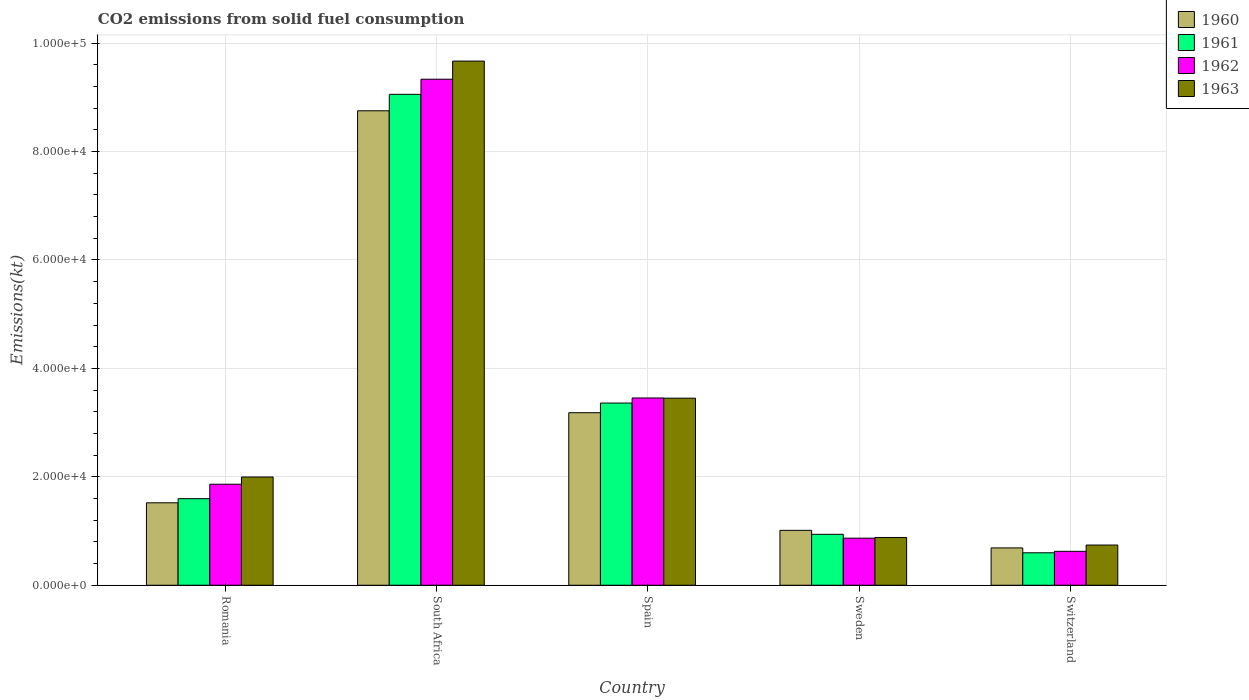How many different coloured bars are there?
Give a very brief answer. 4. How many groups of bars are there?
Provide a succinct answer. 5. Are the number of bars per tick equal to the number of legend labels?
Ensure brevity in your answer.  Yes. What is the label of the 5th group of bars from the left?
Keep it short and to the point. Switzerland. In how many cases, is the number of bars for a given country not equal to the number of legend labels?
Your answer should be compact. 0. What is the amount of CO2 emitted in 1962 in Spain?
Offer a terse response. 3.45e+04. Across all countries, what is the maximum amount of CO2 emitted in 1960?
Provide a short and direct response. 8.75e+04. Across all countries, what is the minimum amount of CO2 emitted in 1963?
Keep it short and to the point. 7414.67. In which country was the amount of CO2 emitted in 1960 maximum?
Keep it short and to the point. South Africa. In which country was the amount of CO2 emitted in 1960 minimum?
Offer a very short reply. Switzerland. What is the total amount of CO2 emitted in 1962 in the graph?
Provide a short and direct response. 1.61e+05. What is the difference between the amount of CO2 emitted in 1963 in Spain and that in Switzerland?
Your answer should be compact. 2.71e+04. What is the difference between the amount of CO2 emitted in 1962 in Spain and the amount of CO2 emitted in 1961 in Romania?
Ensure brevity in your answer.  1.86e+04. What is the average amount of CO2 emitted in 1961 per country?
Your response must be concise. 3.11e+04. What is the difference between the amount of CO2 emitted of/in 1960 and amount of CO2 emitted of/in 1963 in South Africa?
Give a very brief answer. -9167.5. In how many countries, is the amount of CO2 emitted in 1960 greater than 56000 kt?
Offer a very short reply. 1. What is the ratio of the amount of CO2 emitted in 1962 in Romania to that in Switzerland?
Provide a succinct answer. 2.98. What is the difference between the highest and the second highest amount of CO2 emitted in 1963?
Your answer should be very brief. 6.22e+04. What is the difference between the highest and the lowest amount of CO2 emitted in 1963?
Offer a very short reply. 8.93e+04. What does the 2nd bar from the left in Spain represents?
Make the answer very short. 1961. Are the values on the major ticks of Y-axis written in scientific E-notation?
Make the answer very short. Yes. Does the graph contain any zero values?
Offer a very short reply. No. Does the graph contain grids?
Your response must be concise. Yes. How many legend labels are there?
Offer a very short reply. 4. How are the legend labels stacked?
Offer a very short reply. Vertical. What is the title of the graph?
Ensure brevity in your answer.  CO2 emissions from solid fuel consumption. What is the label or title of the X-axis?
Your response must be concise. Country. What is the label or title of the Y-axis?
Give a very brief answer. Emissions(kt). What is the Emissions(kt) of 1960 in Romania?
Make the answer very short. 1.52e+04. What is the Emissions(kt) of 1961 in Romania?
Provide a short and direct response. 1.60e+04. What is the Emissions(kt) of 1962 in Romania?
Give a very brief answer. 1.86e+04. What is the Emissions(kt) in 1963 in Romania?
Provide a succinct answer. 2.00e+04. What is the Emissions(kt) of 1960 in South Africa?
Your response must be concise. 8.75e+04. What is the Emissions(kt) in 1961 in South Africa?
Your answer should be compact. 9.05e+04. What is the Emissions(kt) in 1962 in South Africa?
Provide a succinct answer. 9.33e+04. What is the Emissions(kt) of 1963 in South Africa?
Ensure brevity in your answer.  9.67e+04. What is the Emissions(kt) of 1960 in Spain?
Provide a short and direct response. 3.18e+04. What is the Emissions(kt) in 1961 in Spain?
Keep it short and to the point. 3.36e+04. What is the Emissions(kt) in 1962 in Spain?
Your answer should be very brief. 3.45e+04. What is the Emissions(kt) in 1963 in Spain?
Give a very brief answer. 3.45e+04. What is the Emissions(kt) of 1960 in Sweden?
Your answer should be compact. 1.01e+04. What is the Emissions(kt) in 1961 in Sweden?
Make the answer very short. 9394.85. What is the Emissions(kt) in 1962 in Sweden?
Your answer should be compact. 8683.46. What is the Emissions(kt) of 1963 in Sweden?
Ensure brevity in your answer.  8808.13. What is the Emissions(kt) of 1960 in Switzerland?
Provide a succinct answer. 6882.96. What is the Emissions(kt) of 1961 in Switzerland?
Offer a very short reply. 5984.54. What is the Emissions(kt) of 1962 in Switzerland?
Provide a succinct answer. 6255.9. What is the Emissions(kt) of 1963 in Switzerland?
Keep it short and to the point. 7414.67. Across all countries, what is the maximum Emissions(kt) in 1960?
Offer a terse response. 8.75e+04. Across all countries, what is the maximum Emissions(kt) in 1961?
Provide a short and direct response. 9.05e+04. Across all countries, what is the maximum Emissions(kt) in 1962?
Keep it short and to the point. 9.33e+04. Across all countries, what is the maximum Emissions(kt) of 1963?
Your response must be concise. 9.67e+04. Across all countries, what is the minimum Emissions(kt) in 1960?
Give a very brief answer. 6882.96. Across all countries, what is the minimum Emissions(kt) in 1961?
Provide a short and direct response. 5984.54. Across all countries, what is the minimum Emissions(kt) of 1962?
Your answer should be compact. 6255.9. Across all countries, what is the minimum Emissions(kt) of 1963?
Provide a short and direct response. 7414.67. What is the total Emissions(kt) in 1960 in the graph?
Your answer should be very brief. 1.52e+05. What is the total Emissions(kt) of 1961 in the graph?
Ensure brevity in your answer.  1.55e+05. What is the total Emissions(kt) of 1962 in the graph?
Your response must be concise. 1.61e+05. What is the total Emissions(kt) of 1963 in the graph?
Make the answer very short. 1.67e+05. What is the difference between the Emissions(kt) of 1960 in Romania and that in South Africa?
Provide a succinct answer. -7.23e+04. What is the difference between the Emissions(kt) in 1961 in Romania and that in South Africa?
Provide a succinct answer. -7.46e+04. What is the difference between the Emissions(kt) in 1962 in Romania and that in South Africa?
Ensure brevity in your answer.  -7.47e+04. What is the difference between the Emissions(kt) in 1963 in Romania and that in South Africa?
Your response must be concise. -7.67e+04. What is the difference between the Emissions(kt) of 1960 in Romania and that in Spain?
Ensure brevity in your answer.  -1.66e+04. What is the difference between the Emissions(kt) in 1961 in Romania and that in Spain?
Ensure brevity in your answer.  -1.76e+04. What is the difference between the Emissions(kt) in 1962 in Romania and that in Spain?
Offer a very short reply. -1.59e+04. What is the difference between the Emissions(kt) in 1963 in Romania and that in Spain?
Offer a terse response. -1.45e+04. What is the difference between the Emissions(kt) of 1960 in Romania and that in Sweden?
Your answer should be very brief. 5078.8. What is the difference between the Emissions(kt) of 1961 in Romania and that in Sweden?
Give a very brief answer. 6574.93. What is the difference between the Emissions(kt) in 1962 in Romania and that in Sweden?
Your answer should be compact. 9948.57. What is the difference between the Emissions(kt) of 1963 in Romania and that in Sweden?
Offer a terse response. 1.12e+04. What is the difference between the Emissions(kt) in 1960 in Romania and that in Switzerland?
Provide a succinct answer. 8320.42. What is the difference between the Emissions(kt) in 1961 in Romania and that in Switzerland?
Provide a short and direct response. 9985.24. What is the difference between the Emissions(kt) in 1962 in Romania and that in Switzerland?
Your answer should be compact. 1.24e+04. What is the difference between the Emissions(kt) of 1963 in Romania and that in Switzerland?
Your answer should be very brief. 1.26e+04. What is the difference between the Emissions(kt) of 1960 in South Africa and that in Spain?
Provide a succinct answer. 5.57e+04. What is the difference between the Emissions(kt) of 1961 in South Africa and that in Spain?
Your answer should be very brief. 5.69e+04. What is the difference between the Emissions(kt) of 1962 in South Africa and that in Spain?
Offer a very short reply. 5.88e+04. What is the difference between the Emissions(kt) of 1963 in South Africa and that in Spain?
Offer a terse response. 6.22e+04. What is the difference between the Emissions(kt) of 1960 in South Africa and that in Sweden?
Give a very brief answer. 7.74e+04. What is the difference between the Emissions(kt) of 1961 in South Africa and that in Sweden?
Give a very brief answer. 8.12e+04. What is the difference between the Emissions(kt) in 1962 in South Africa and that in Sweden?
Keep it short and to the point. 8.47e+04. What is the difference between the Emissions(kt) of 1963 in South Africa and that in Sweden?
Ensure brevity in your answer.  8.79e+04. What is the difference between the Emissions(kt) in 1960 in South Africa and that in Switzerland?
Provide a short and direct response. 8.06e+04. What is the difference between the Emissions(kt) of 1961 in South Africa and that in Switzerland?
Offer a very short reply. 8.46e+04. What is the difference between the Emissions(kt) of 1962 in South Africa and that in Switzerland?
Keep it short and to the point. 8.71e+04. What is the difference between the Emissions(kt) in 1963 in South Africa and that in Switzerland?
Provide a succinct answer. 8.93e+04. What is the difference between the Emissions(kt) in 1960 in Spain and that in Sweden?
Keep it short and to the point. 2.17e+04. What is the difference between the Emissions(kt) in 1961 in Spain and that in Sweden?
Offer a very short reply. 2.42e+04. What is the difference between the Emissions(kt) of 1962 in Spain and that in Sweden?
Offer a very short reply. 2.59e+04. What is the difference between the Emissions(kt) in 1963 in Spain and that in Sweden?
Give a very brief answer. 2.57e+04. What is the difference between the Emissions(kt) in 1960 in Spain and that in Switzerland?
Ensure brevity in your answer.  2.49e+04. What is the difference between the Emissions(kt) in 1961 in Spain and that in Switzerland?
Make the answer very short. 2.76e+04. What is the difference between the Emissions(kt) in 1962 in Spain and that in Switzerland?
Offer a very short reply. 2.83e+04. What is the difference between the Emissions(kt) in 1963 in Spain and that in Switzerland?
Your response must be concise. 2.71e+04. What is the difference between the Emissions(kt) of 1960 in Sweden and that in Switzerland?
Your response must be concise. 3241.63. What is the difference between the Emissions(kt) in 1961 in Sweden and that in Switzerland?
Your answer should be very brief. 3410.31. What is the difference between the Emissions(kt) in 1962 in Sweden and that in Switzerland?
Provide a short and direct response. 2427.55. What is the difference between the Emissions(kt) of 1963 in Sweden and that in Switzerland?
Provide a short and direct response. 1393.46. What is the difference between the Emissions(kt) in 1960 in Romania and the Emissions(kt) in 1961 in South Africa?
Keep it short and to the point. -7.53e+04. What is the difference between the Emissions(kt) in 1960 in Romania and the Emissions(kt) in 1962 in South Africa?
Keep it short and to the point. -7.81e+04. What is the difference between the Emissions(kt) in 1960 in Romania and the Emissions(kt) in 1963 in South Africa?
Offer a very short reply. -8.15e+04. What is the difference between the Emissions(kt) in 1961 in Romania and the Emissions(kt) in 1962 in South Africa?
Offer a terse response. -7.74e+04. What is the difference between the Emissions(kt) of 1961 in Romania and the Emissions(kt) of 1963 in South Africa?
Provide a succinct answer. -8.07e+04. What is the difference between the Emissions(kt) in 1962 in Romania and the Emissions(kt) in 1963 in South Africa?
Ensure brevity in your answer.  -7.80e+04. What is the difference between the Emissions(kt) in 1960 in Romania and the Emissions(kt) in 1961 in Spain?
Offer a very short reply. -1.84e+04. What is the difference between the Emissions(kt) in 1960 in Romania and the Emissions(kt) in 1962 in Spain?
Your response must be concise. -1.93e+04. What is the difference between the Emissions(kt) of 1960 in Romania and the Emissions(kt) of 1963 in Spain?
Provide a short and direct response. -1.93e+04. What is the difference between the Emissions(kt) in 1961 in Romania and the Emissions(kt) in 1962 in Spain?
Ensure brevity in your answer.  -1.86e+04. What is the difference between the Emissions(kt) in 1961 in Romania and the Emissions(kt) in 1963 in Spain?
Your answer should be compact. -1.85e+04. What is the difference between the Emissions(kt) in 1962 in Romania and the Emissions(kt) in 1963 in Spain?
Make the answer very short. -1.59e+04. What is the difference between the Emissions(kt) of 1960 in Romania and the Emissions(kt) of 1961 in Sweden?
Offer a terse response. 5808.53. What is the difference between the Emissions(kt) of 1960 in Romania and the Emissions(kt) of 1962 in Sweden?
Your answer should be very brief. 6519.93. What is the difference between the Emissions(kt) of 1960 in Romania and the Emissions(kt) of 1963 in Sweden?
Provide a short and direct response. 6395.25. What is the difference between the Emissions(kt) in 1961 in Romania and the Emissions(kt) in 1962 in Sweden?
Provide a succinct answer. 7286.33. What is the difference between the Emissions(kt) in 1961 in Romania and the Emissions(kt) in 1963 in Sweden?
Ensure brevity in your answer.  7161.65. What is the difference between the Emissions(kt) of 1962 in Romania and the Emissions(kt) of 1963 in Sweden?
Offer a terse response. 9823.89. What is the difference between the Emissions(kt) in 1960 in Romania and the Emissions(kt) in 1961 in Switzerland?
Your response must be concise. 9218.84. What is the difference between the Emissions(kt) of 1960 in Romania and the Emissions(kt) of 1962 in Switzerland?
Ensure brevity in your answer.  8947.48. What is the difference between the Emissions(kt) in 1960 in Romania and the Emissions(kt) in 1963 in Switzerland?
Offer a terse response. 7788.71. What is the difference between the Emissions(kt) in 1961 in Romania and the Emissions(kt) in 1962 in Switzerland?
Offer a terse response. 9713.88. What is the difference between the Emissions(kt) of 1961 in Romania and the Emissions(kt) of 1963 in Switzerland?
Ensure brevity in your answer.  8555.11. What is the difference between the Emissions(kt) of 1962 in Romania and the Emissions(kt) of 1963 in Switzerland?
Your response must be concise. 1.12e+04. What is the difference between the Emissions(kt) of 1960 in South Africa and the Emissions(kt) of 1961 in Spain?
Your response must be concise. 5.39e+04. What is the difference between the Emissions(kt) in 1960 in South Africa and the Emissions(kt) in 1962 in Spain?
Your answer should be very brief. 5.30e+04. What is the difference between the Emissions(kt) in 1960 in South Africa and the Emissions(kt) in 1963 in Spain?
Make the answer very short. 5.30e+04. What is the difference between the Emissions(kt) of 1961 in South Africa and the Emissions(kt) of 1962 in Spain?
Your answer should be very brief. 5.60e+04. What is the difference between the Emissions(kt) of 1961 in South Africa and the Emissions(kt) of 1963 in Spain?
Make the answer very short. 5.60e+04. What is the difference between the Emissions(kt) of 1962 in South Africa and the Emissions(kt) of 1963 in Spain?
Keep it short and to the point. 5.88e+04. What is the difference between the Emissions(kt) of 1960 in South Africa and the Emissions(kt) of 1961 in Sweden?
Give a very brief answer. 7.81e+04. What is the difference between the Emissions(kt) of 1960 in South Africa and the Emissions(kt) of 1962 in Sweden?
Offer a very short reply. 7.88e+04. What is the difference between the Emissions(kt) of 1960 in South Africa and the Emissions(kt) of 1963 in Sweden?
Offer a very short reply. 7.87e+04. What is the difference between the Emissions(kt) of 1961 in South Africa and the Emissions(kt) of 1962 in Sweden?
Keep it short and to the point. 8.19e+04. What is the difference between the Emissions(kt) in 1961 in South Africa and the Emissions(kt) in 1963 in Sweden?
Ensure brevity in your answer.  8.17e+04. What is the difference between the Emissions(kt) in 1962 in South Africa and the Emissions(kt) in 1963 in Sweden?
Ensure brevity in your answer.  8.45e+04. What is the difference between the Emissions(kt) in 1960 in South Africa and the Emissions(kt) in 1961 in Switzerland?
Offer a terse response. 8.15e+04. What is the difference between the Emissions(kt) in 1960 in South Africa and the Emissions(kt) in 1962 in Switzerland?
Keep it short and to the point. 8.13e+04. What is the difference between the Emissions(kt) of 1960 in South Africa and the Emissions(kt) of 1963 in Switzerland?
Offer a very short reply. 8.01e+04. What is the difference between the Emissions(kt) in 1961 in South Africa and the Emissions(kt) in 1962 in Switzerland?
Offer a terse response. 8.43e+04. What is the difference between the Emissions(kt) in 1961 in South Africa and the Emissions(kt) in 1963 in Switzerland?
Make the answer very short. 8.31e+04. What is the difference between the Emissions(kt) of 1962 in South Africa and the Emissions(kt) of 1963 in Switzerland?
Provide a succinct answer. 8.59e+04. What is the difference between the Emissions(kt) in 1960 in Spain and the Emissions(kt) in 1961 in Sweden?
Ensure brevity in your answer.  2.24e+04. What is the difference between the Emissions(kt) in 1960 in Spain and the Emissions(kt) in 1962 in Sweden?
Provide a short and direct response. 2.31e+04. What is the difference between the Emissions(kt) of 1960 in Spain and the Emissions(kt) of 1963 in Sweden?
Offer a very short reply. 2.30e+04. What is the difference between the Emissions(kt) in 1961 in Spain and the Emissions(kt) in 1962 in Sweden?
Give a very brief answer. 2.49e+04. What is the difference between the Emissions(kt) of 1961 in Spain and the Emissions(kt) of 1963 in Sweden?
Your response must be concise. 2.48e+04. What is the difference between the Emissions(kt) in 1962 in Spain and the Emissions(kt) in 1963 in Sweden?
Ensure brevity in your answer.  2.57e+04. What is the difference between the Emissions(kt) in 1960 in Spain and the Emissions(kt) in 1961 in Switzerland?
Give a very brief answer. 2.58e+04. What is the difference between the Emissions(kt) of 1960 in Spain and the Emissions(kt) of 1962 in Switzerland?
Provide a succinct answer. 2.56e+04. What is the difference between the Emissions(kt) in 1960 in Spain and the Emissions(kt) in 1963 in Switzerland?
Offer a very short reply. 2.44e+04. What is the difference between the Emissions(kt) in 1961 in Spain and the Emissions(kt) in 1962 in Switzerland?
Offer a terse response. 2.73e+04. What is the difference between the Emissions(kt) in 1961 in Spain and the Emissions(kt) in 1963 in Switzerland?
Provide a short and direct response. 2.62e+04. What is the difference between the Emissions(kt) of 1962 in Spain and the Emissions(kt) of 1963 in Switzerland?
Offer a terse response. 2.71e+04. What is the difference between the Emissions(kt) in 1960 in Sweden and the Emissions(kt) in 1961 in Switzerland?
Give a very brief answer. 4140.04. What is the difference between the Emissions(kt) in 1960 in Sweden and the Emissions(kt) in 1962 in Switzerland?
Keep it short and to the point. 3868.68. What is the difference between the Emissions(kt) of 1960 in Sweden and the Emissions(kt) of 1963 in Switzerland?
Keep it short and to the point. 2709.91. What is the difference between the Emissions(kt) in 1961 in Sweden and the Emissions(kt) in 1962 in Switzerland?
Keep it short and to the point. 3138.95. What is the difference between the Emissions(kt) of 1961 in Sweden and the Emissions(kt) of 1963 in Switzerland?
Provide a succinct answer. 1980.18. What is the difference between the Emissions(kt) of 1962 in Sweden and the Emissions(kt) of 1963 in Switzerland?
Ensure brevity in your answer.  1268.78. What is the average Emissions(kt) in 1960 per country?
Ensure brevity in your answer.  3.03e+04. What is the average Emissions(kt) in 1961 per country?
Ensure brevity in your answer.  3.11e+04. What is the average Emissions(kt) of 1962 per country?
Your response must be concise. 3.23e+04. What is the average Emissions(kt) in 1963 per country?
Give a very brief answer. 3.35e+04. What is the difference between the Emissions(kt) in 1960 and Emissions(kt) in 1961 in Romania?
Your response must be concise. -766.4. What is the difference between the Emissions(kt) of 1960 and Emissions(kt) of 1962 in Romania?
Offer a terse response. -3428.64. What is the difference between the Emissions(kt) of 1960 and Emissions(kt) of 1963 in Romania?
Provide a short and direct response. -4763.43. What is the difference between the Emissions(kt) in 1961 and Emissions(kt) in 1962 in Romania?
Offer a terse response. -2662.24. What is the difference between the Emissions(kt) in 1961 and Emissions(kt) in 1963 in Romania?
Provide a short and direct response. -3997.03. What is the difference between the Emissions(kt) in 1962 and Emissions(kt) in 1963 in Romania?
Make the answer very short. -1334.79. What is the difference between the Emissions(kt) in 1960 and Emissions(kt) in 1961 in South Africa?
Your answer should be very brief. -3032.61. What is the difference between the Emissions(kt) in 1960 and Emissions(kt) in 1962 in South Africa?
Make the answer very short. -5823.2. What is the difference between the Emissions(kt) in 1960 and Emissions(kt) in 1963 in South Africa?
Provide a succinct answer. -9167.5. What is the difference between the Emissions(kt) of 1961 and Emissions(kt) of 1962 in South Africa?
Give a very brief answer. -2790.59. What is the difference between the Emissions(kt) in 1961 and Emissions(kt) in 1963 in South Africa?
Ensure brevity in your answer.  -6134.89. What is the difference between the Emissions(kt) of 1962 and Emissions(kt) of 1963 in South Africa?
Your answer should be compact. -3344.3. What is the difference between the Emissions(kt) in 1960 and Emissions(kt) in 1961 in Spain?
Provide a short and direct response. -1782.16. What is the difference between the Emissions(kt) of 1960 and Emissions(kt) of 1962 in Spain?
Make the answer very short. -2720.91. What is the difference between the Emissions(kt) in 1960 and Emissions(kt) in 1963 in Spain?
Your answer should be compact. -2684.24. What is the difference between the Emissions(kt) of 1961 and Emissions(kt) of 1962 in Spain?
Make the answer very short. -938.75. What is the difference between the Emissions(kt) in 1961 and Emissions(kt) in 1963 in Spain?
Make the answer very short. -902.08. What is the difference between the Emissions(kt) of 1962 and Emissions(kt) of 1963 in Spain?
Provide a short and direct response. 36.67. What is the difference between the Emissions(kt) in 1960 and Emissions(kt) in 1961 in Sweden?
Your answer should be very brief. 729.73. What is the difference between the Emissions(kt) in 1960 and Emissions(kt) in 1962 in Sweden?
Provide a short and direct response. 1441.13. What is the difference between the Emissions(kt) of 1960 and Emissions(kt) of 1963 in Sweden?
Make the answer very short. 1316.45. What is the difference between the Emissions(kt) of 1961 and Emissions(kt) of 1962 in Sweden?
Offer a very short reply. 711.4. What is the difference between the Emissions(kt) in 1961 and Emissions(kt) in 1963 in Sweden?
Your answer should be very brief. 586.72. What is the difference between the Emissions(kt) in 1962 and Emissions(kt) in 1963 in Sweden?
Offer a terse response. -124.68. What is the difference between the Emissions(kt) of 1960 and Emissions(kt) of 1961 in Switzerland?
Provide a short and direct response. 898.41. What is the difference between the Emissions(kt) in 1960 and Emissions(kt) in 1962 in Switzerland?
Offer a terse response. 627.06. What is the difference between the Emissions(kt) of 1960 and Emissions(kt) of 1963 in Switzerland?
Keep it short and to the point. -531.72. What is the difference between the Emissions(kt) in 1961 and Emissions(kt) in 1962 in Switzerland?
Make the answer very short. -271.36. What is the difference between the Emissions(kt) in 1961 and Emissions(kt) in 1963 in Switzerland?
Offer a terse response. -1430.13. What is the difference between the Emissions(kt) in 1962 and Emissions(kt) in 1963 in Switzerland?
Your response must be concise. -1158.77. What is the ratio of the Emissions(kt) of 1960 in Romania to that in South Africa?
Provide a short and direct response. 0.17. What is the ratio of the Emissions(kt) in 1961 in Romania to that in South Africa?
Offer a terse response. 0.18. What is the ratio of the Emissions(kt) in 1962 in Romania to that in South Africa?
Make the answer very short. 0.2. What is the ratio of the Emissions(kt) in 1963 in Romania to that in South Africa?
Give a very brief answer. 0.21. What is the ratio of the Emissions(kt) of 1960 in Romania to that in Spain?
Give a very brief answer. 0.48. What is the ratio of the Emissions(kt) in 1961 in Romania to that in Spain?
Keep it short and to the point. 0.48. What is the ratio of the Emissions(kt) of 1962 in Romania to that in Spain?
Give a very brief answer. 0.54. What is the ratio of the Emissions(kt) in 1963 in Romania to that in Spain?
Provide a succinct answer. 0.58. What is the ratio of the Emissions(kt) in 1960 in Romania to that in Sweden?
Provide a short and direct response. 1.5. What is the ratio of the Emissions(kt) in 1961 in Romania to that in Sweden?
Your response must be concise. 1.7. What is the ratio of the Emissions(kt) of 1962 in Romania to that in Sweden?
Make the answer very short. 2.15. What is the ratio of the Emissions(kt) of 1963 in Romania to that in Sweden?
Provide a short and direct response. 2.27. What is the ratio of the Emissions(kt) in 1960 in Romania to that in Switzerland?
Offer a very short reply. 2.21. What is the ratio of the Emissions(kt) in 1961 in Romania to that in Switzerland?
Provide a succinct answer. 2.67. What is the ratio of the Emissions(kt) in 1962 in Romania to that in Switzerland?
Provide a succinct answer. 2.98. What is the ratio of the Emissions(kt) in 1963 in Romania to that in Switzerland?
Offer a very short reply. 2.69. What is the ratio of the Emissions(kt) in 1960 in South Africa to that in Spain?
Give a very brief answer. 2.75. What is the ratio of the Emissions(kt) in 1961 in South Africa to that in Spain?
Keep it short and to the point. 2.69. What is the ratio of the Emissions(kt) in 1962 in South Africa to that in Spain?
Offer a very short reply. 2.7. What is the ratio of the Emissions(kt) in 1963 in South Africa to that in Spain?
Your answer should be very brief. 2.8. What is the ratio of the Emissions(kt) of 1960 in South Africa to that in Sweden?
Your answer should be compact. 8.64. What is the ratio of the Emissions(kt) of 1961 in South Africa to that in Sweden?
Provide a short and direct response. 9.64. What is the ratio of the Emissions(kt) of 1962 in South Africa to that in Sweden?
Give a very brief answer. 10.75. What is the ratio of the Emissions(kt) of 1963 in South Africa to that in Sweden?
Provide a succinct answer. 10.98. What is the ratio of the Emissions(kt) of 1960 in South Africa to that in Switzerland?
Offer a very short reply. 12.71. What is the ratio of the Emissions(kt) of 1961 in South Africa to that in Switzerland?
Offer a terse response. 15.13. What is the ratio of the Emissions(kt) of 1962 in South Africa to that in Switzerland?
Provide a short and direct response. 14.92. What is the ratio of the Emissions(kt) of 1963 in South Africa to that in Switzerland?
Provide a short and direct response. 13.04. What is the ratio of the Emissions(kt) in 1960 in Spain to that in Sweden?
Ensure brevity in your answer.  3.14. What is the ratio of the Emissions(kt) of 1961 in Spain to that in Sweden?
Your answer should be very brief. 3.58. What is the ratio of the Emissions(kt) of 1962 in Spain to that in Sweden?
Your answer should be very brief. 3.98. What is the ratio of the Emissions(kt) of 1963 in Spain to that in Sweden?
Your answer should be very brief. 3.92. What is the ratio of the Emissions(kt) in 1960 in Spain to that in Switzerland?
Your answer should be very brief. 4.62. What is the ratio of the Emissions(kt) in 1961 in Spain to that in Switzerland?
Make the answer very short. 5.62. What is the ratio of the Emissions(kt) in 1962 in Spain to that in Switzerland?
Offer a terse response. 5.52. What is the ratio of the Emissions(kt) in 1963 in Spain to that in Switzerland?
Offer a very short reply. 4.65. What is the ratio of the Emissions(kt) of 1960 in Sweden to that in Switzerland?
Offer a very short reply. 1.47. What is the ratio of the Emissions(kt) of 1961 in Sweden to that in Switzerland?
Provide a succinct answer. 1.57. What is the ratio of the Emissions(kt) of 1962 in Sweden to that in Switzerland?
Offer a terse response. 1.39. What is the ratio of the Emissions(kt) in 1963 in Sweden to that in Switzerland?
Your answer should be very brief. 1.19. What is the difference between the highest and the second highest Emissions(kt) of 1960?
Provide a succinct answer. 5.57e+04. What is the difference between the highest and the second highest Emissions(kt) of 1961?
Give a very brief answer. 5.69e+04. What is the difference between the highest and the second highest Emissions(kt) in 1962?
Provide a succinct answer. 5.88e+04. What is the difference between the highest and the second highest Emissions(kt) of 1963?
Your answer should be compact. 6.22e+04. What is the difference between the highest and the lowest Emissions(kt) of 1960?
Offer a very short reply. 8.06e+04. What is the difference between the highest and the lowest Emissions(kt) of 1961?
Your response must be concise. 8.46e+04. What is the difference between the highest and the lowest Emissions(kt) of 1962?
Provide a succinct answer. 8.71e+04. What is the difference between the highest and the lowest Emissions(kt) of 1963?
Ensure brevity in your answer.  8.93e+04. 